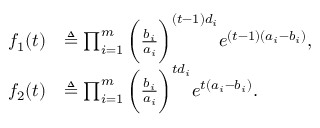<formula> <loc_0><loc_0><loc_500><loc_500>\begin{array} { r l } { f _ { 1 } ( t ) } & { \triangle q \prod _ { i = 1 } ^ { m } \left ( \frac { b _ { i } } { a _ { i } } \right ) ^ { ( t - 1 ) d _ { i } } e ^ { ( t - 1 ) ( a _ { i } - b _ { i } ) } , } \\ { f _ { 2 } ( t ) } & { \triangle q \prod _ { i = 1 } ^ { m } \left ( \frac { b _ { i } } { a _ { i } } \right ) ^ { t d _ { i } } e ^ { t ( a _ { i } - b _ { i } ) } . } \end{array}</formula> 